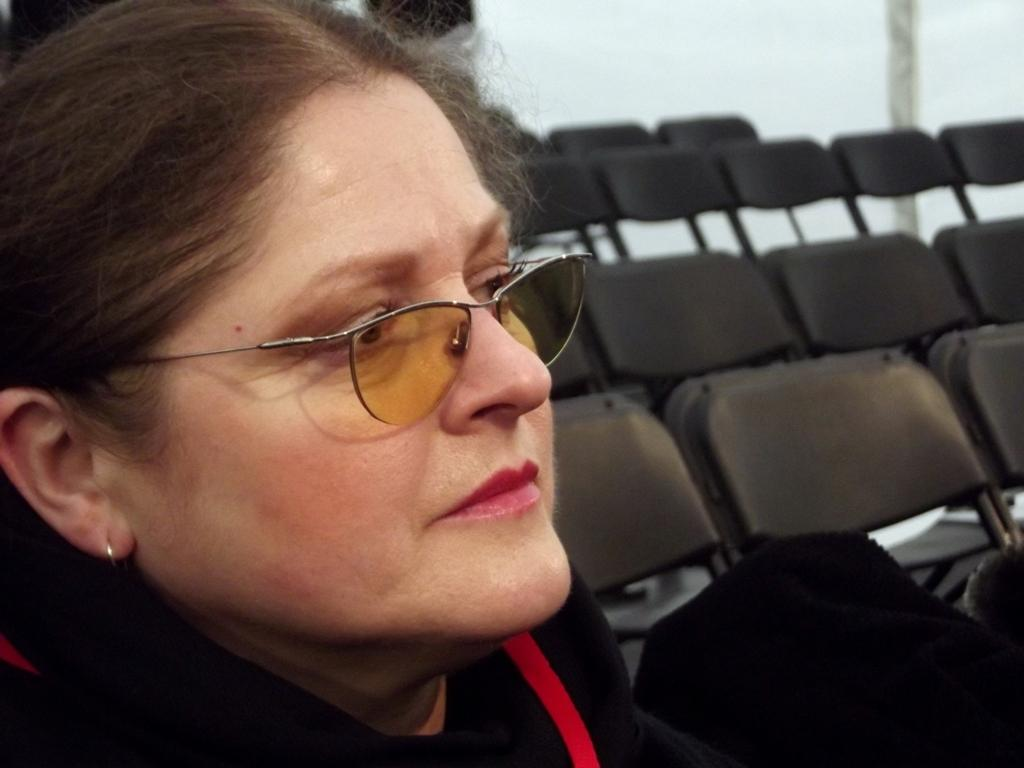Who is present in the image? There is a lady in the image. What accessory is the lady wearing? The lady is wearing glasses. What can be seen in the background of the image? There are chairs in the background of the image. What type of celery is the lady holding in the image? There is no celery present in the image; the lady is not holding any vegetables. 